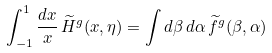<formula> <loc_0><loc_0><loc_500><loc_500>\int _ { - 1 } ^ { 1 } \frac { d x } { x } \, \widetilde { H } ^ { g } ( x , \eta ) = \int d \beta \, d \alpha \, \widetilde { f } ^ { g } ( \beta , \alpha )</formula> 